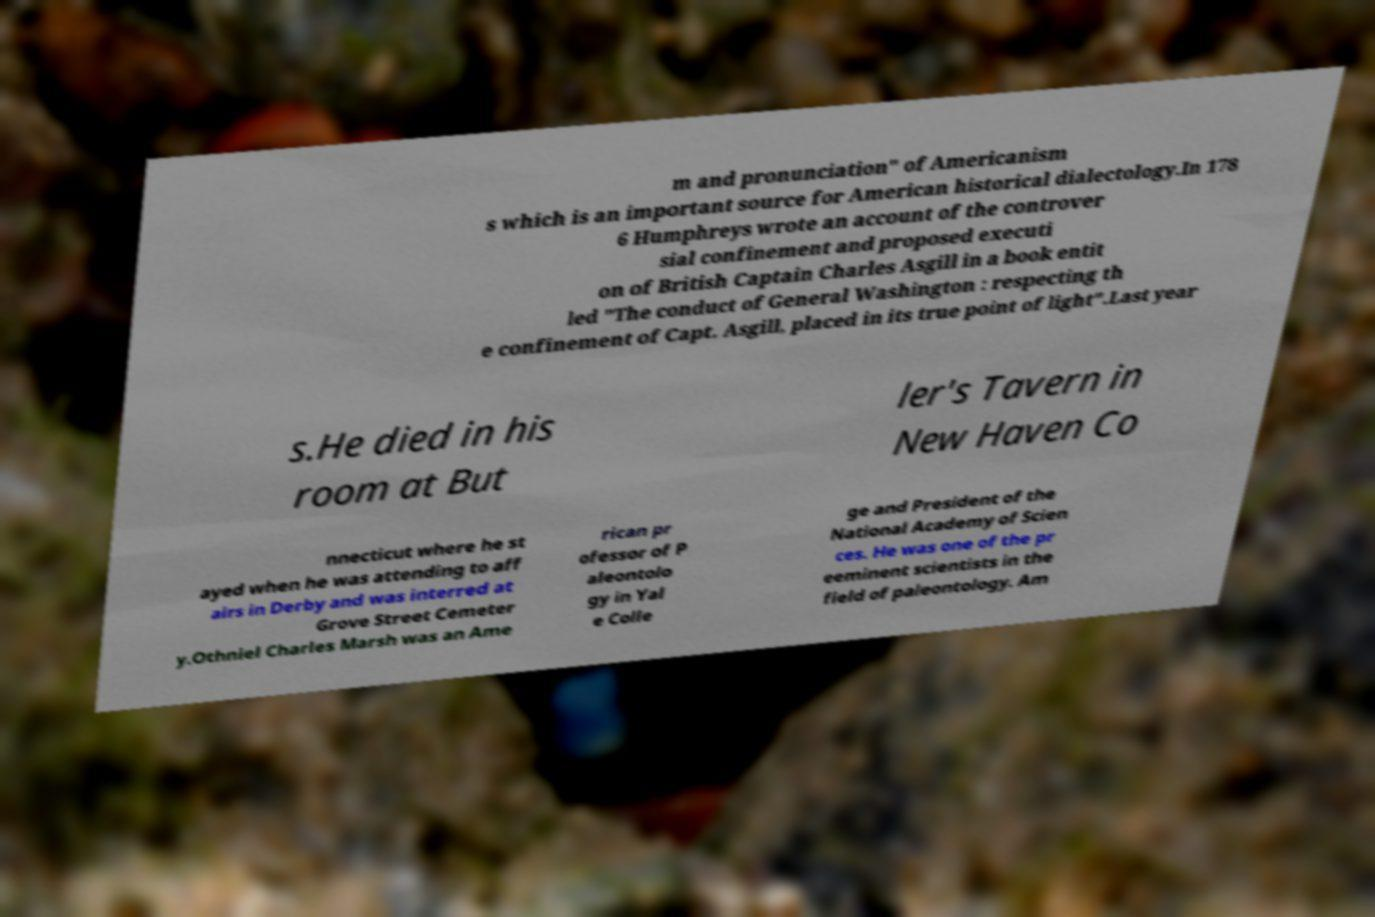Could you assist in decoding the text presented in this image and type it out clearly? m and pronunciation" of Americanism s which is an important source for American historical dialectology.In 178 6 Humphreys wrote an account of the controver sial confinement and proposed executi on of British Captain Charles Asgill in a book entit led "The conduct of General Washington : respecting th e confinement of Capt. Asgill, placed in its true point of light".Last year s.He died in his room at But ler's Tavern in New Haven Co nnecticut where he st ayed when he was attending to aff airs in Derby and was interred at Grove Street Cemeter y.Othniel Charles Marsh was an Ame rican pr ofessor of P aleontolo gy in Yal e Colle ge and President of the National Academy of Scien ces. He was one of the pr eeminent scientists in the field of paleontology. Am 